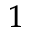Convert formula to latex. <formula><loc_0><loc_0><loc_500><loc_500>_ { 1 }</formula> 